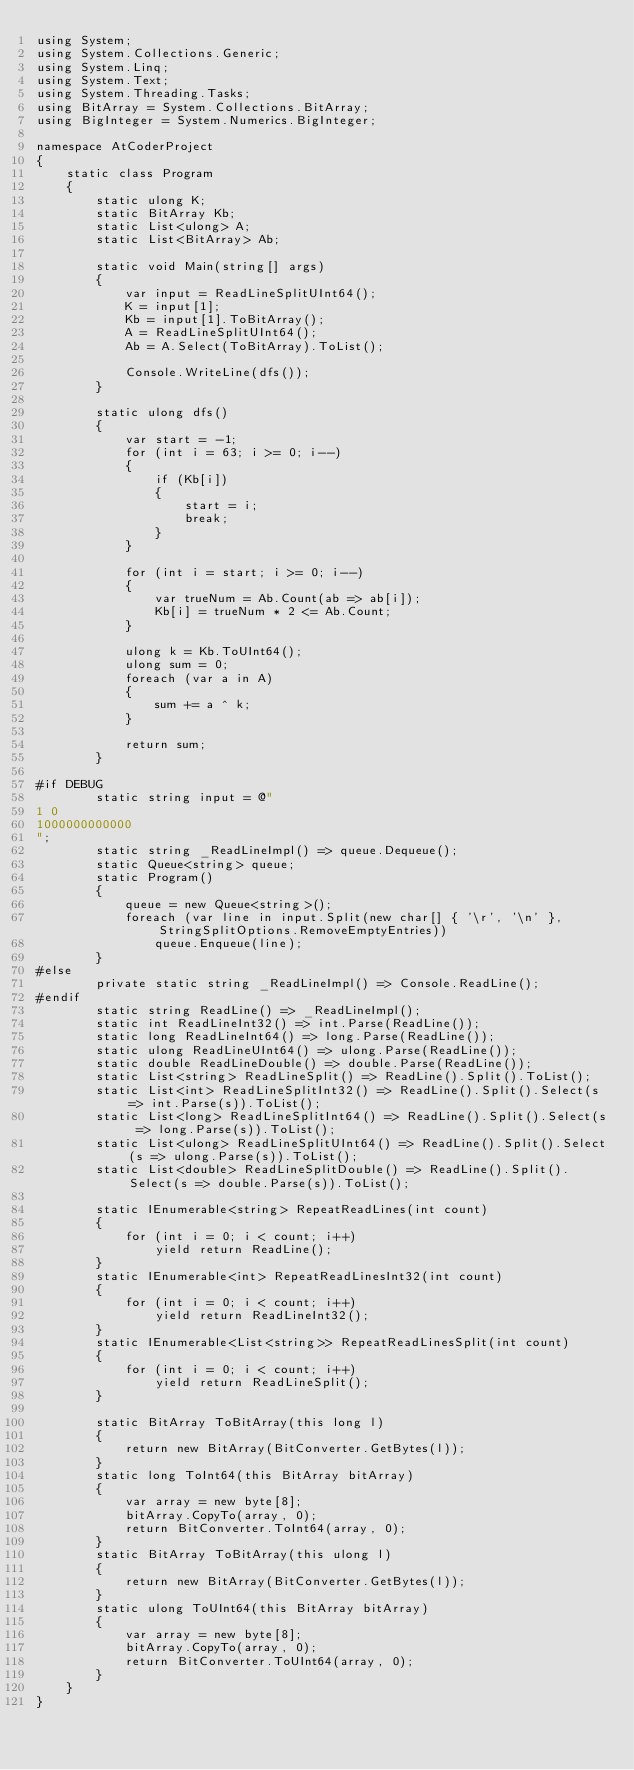Convert code to text. <code><loc_0><loc_0><loc_500><loc_500><_C#_>using System;
using System.Collections.Generic;
using System.Linq;
using System.Text;
using System.Threading.Tasks;
using BitArray = System.Collections.BitArray;
using BigInteger = System.Numerics.BigInteger;

namespace AtCoderProject
{
    static class Program
    {
        static ulong K;
        static BitArray Kb;
        static List<ulong> A;
        static List<BitArray> Ab;

        static void Main(string[] args)
        {
            var input = ReadLineSplitUInt64();
            K = input[1];
            Kb = input[1].ToBitArray();
            A = ReadLineSplitUInt64();
            Ab = A.Select(ToBitArray).ToList();

            Console.WriteLine(dfs());
        }

        static ulong dfs()
        {
            var start = -1;
            for (int i = 63; i >= 0; i--)
            {
                if (Kb[i])
                {
                    start = i;
                    break;
                }
            }

            for (int i = start; i >= 0; i--)
            {
                var trueNum = Ab.Count(ab => ab[i]);
                Kb[i] = trueNum * 2 <= Ab.Count;
            }

            ulong k = Kb.ToUInt64();
            ulong sum = 0;
            foreach (var a in A)
            {
                sum += a ^ k;
            }

            return sum;
        }

#if DEBUG
        static string input = @"
1 0
1000000000000
";
        static string _ReadLineImpl() => queue.Dequeue();
        static Queue<string> queue;
        static Program()
        {
            queue = new Queue<string>();
            foreach (var line in input.Split(new char[] { '\r', '\n' }, StringSplitOptions.RemoveEmptyEntries))
                queue.Enqueue(line);
        }
#else
        private static string _ReadLineImpl() => Console.ReadLine();
#endif
        static string ReadLine() => _ReadLineImpl();
        static int ReadLineInt32() => int.Parse(ReadLine());
        static long ReadLineInt64() => long.Parse(ReadLine());
        static ulong ReadLineUInt64() => ulong.Parse(ReadLine());
        static double ReadLineDouble() => double.Parse(ReadLine());
        static List<string> ReadLineSplit() => ReadLine().Split().ToList();
        static List<int> ReadLineSplitInt32() => ReadLine().Split().Select(s => int.Parse(s)).ToList();
        static List<long> ReadLineSplitInt64() => ReadLine().Split().Select(s => long.Parse(s)).ToList();
        static List<ulong> ReadLineSplitUInt64() => ReadLine().Split().Select(s => ulong.Parse(s)).ToList();
        static List<double> ReadLineSplitDouble() => ReadLine().Split().Select(s => double.Parse(s)).ToList();

        static IEnumerable<string> RepeatReadLines(int count)
        {
            for (int i = 0; i < count; i++)
                yield return ReadLine();
        }
        static IEnumerable<int> RepeatReadLinesInt32(int count)
        {
            for (int i = 0; i < count; i++)
                yield return ReadLineInt32();
        }
        static IEnumerable<List<string>> RepeatReadLinesSplit(int count)
        {
            for (int i = 0; i < count; i++)
                yield return ReadLineSplit();
        }

        static BitArray ToBitArray(this long l)
        {
            return new BitArray(BitConverter.GetBytes(l));
        }
        static long ToInt64(this BitArray bitArray)
        {
            var array = new byte[8];
            bitArray.CopyTo(array, 0);
            return BitConverter.ToInt64(array, 0);
        }
        static BitArray ToBitArray(this ulong l)
        {
            return new BitArray(BitConverter.GetBytes(l));
        }
        static ulong ToUInt64(this BitArray bitArray)
        {
            var array = new byte[8];
            bitArray.CopyTo(array, 0);
            return BitConverter.ToUInt64(array, 0);
        }
    }
}
</code> 